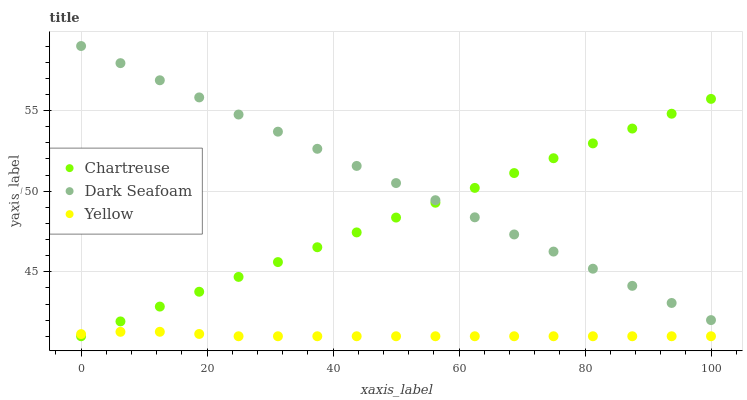Does Yellow have the minimum area under the curve?
Answer yes or no. Yes. Does Dark Seafoam have the maximum area under the curve?
Answer yes or no. Yes. Does Dark Seafoam have the minimum area under the curve?
Answer yes or no. No. Does Yellow have the maximum area under the curve?
Answer yes or no. No. Is Chartreuse the smoothest?
Answer yes or no. Yes. Is Yellow the roughest?
Answer yes or no. Yes. Is Dark Seafoam the smoothest?
Answer yes or no. No. Is Dark Seafoam the roughest?
Answer yes or no. No. Does Chartreuse have the lowest value?
Answer yes or no. Yes. Does Dark Seafoam have the lowest value?
Answer yes or no. No. Does Dark Seafoam have the highest value?
Answer yes or no. Yes. Does Yellow have the highest value?
Answer yes or no. No. Is Yellow less than Dark Seafoam?
Answer yes or no. Yes. Is Dark Seafoam greater than Yellow?
Answer yes or no. Yes. Does Chartreuse intersect Dark Seafoam?
Answer yes or no. Yes. Is Chartreuse less than Dark Seafoam?
Answer yes or no. No. Is Chartreuse greater than Dark Seafoam?
Answer yes or no. No. Does Yellow intersect Dark Seafoam?
Answer yes or no. No. 